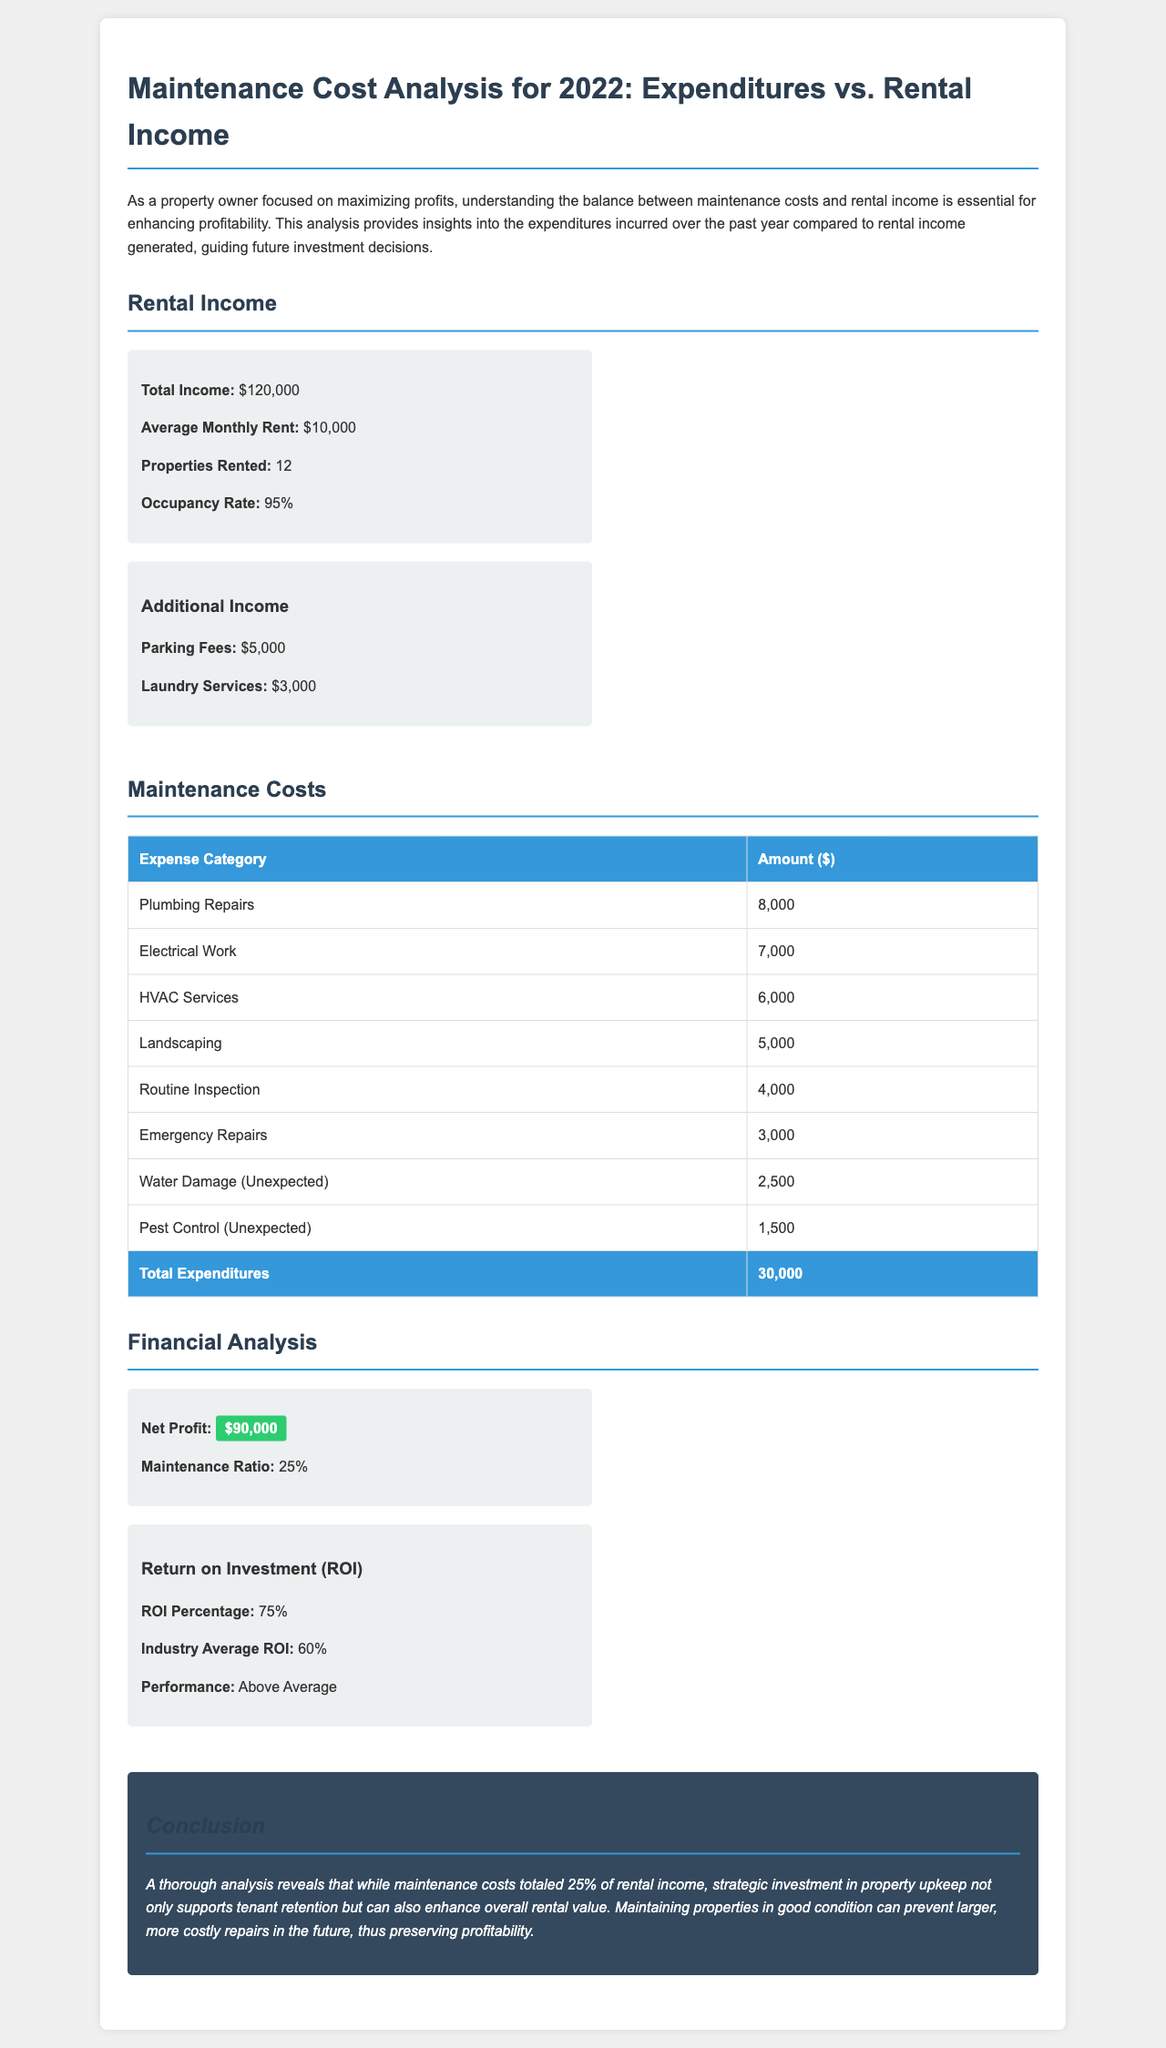What is the total income? The total income is explicitly stated in the document under rental income, which totals $120,000.
Answer: $120,000 What is the average monthly rent? The average monthly rent is provided in the rental income section as $10,000.
Answer: $10,000 What are the total expenditures? The document lists the total expenditures at the end of the maintenance costs table, which amount to $30,000.
Answer: $30,000 What is the net profit? The net profit is indicated in the financial analysis section, which states it is $90,000.
Answer: $90,000 What is the maintenance ratio? The maintenance ratio is calculated as a percentage and stated as 25% in the financial analysis section.
Answer: 25% What is the return on investment (ROI) percentage? The ROI percentage is specified in the document as 75%.
Answer: 75% Which expense had the highest cost? The expense category with the highest cost is plumbing repairs, amounting to $8,000 as seen in the maintenance costs table.
Answer: 8,000 How much did the parking fees generate? The document indicates that parking fees generated an additional income of $5,000.
Answer: $5,000 What was the occupancy rate? The occupancy rate is mentioned in the rental income section, which states it is 95%.
Answer: 95% 